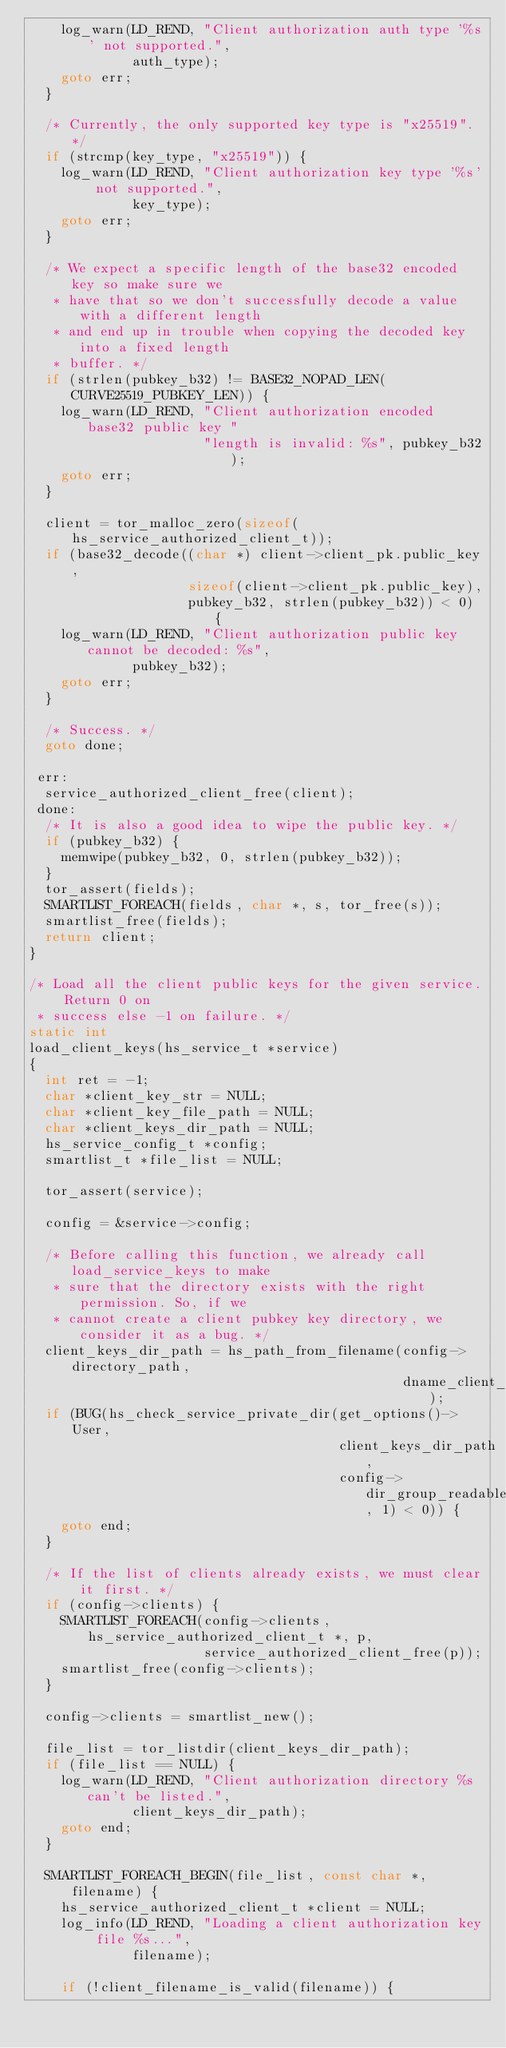Convert code to text. <code><loc_0><loc_0><loc_500><loc_500><_C_>    log_warn(LD_REND, "Client authorization auth type '%s' not supported.",
             auth_type);
    goto err;
  }

  /* Currently, the only supported key type is "x25519". */
  if (strcmp(key_type, "x25519")) {
    log_warn(LD_REND, "Client authorization key type '%s' not supported.",
             key_type);
    goto err;
  }

  /* We expect a specific length of the base32 encoded key so make sure we
   * have that so we don't successfully decode a value with a different length
   * and end up in trouble when copying the decoded key into a fixed length
   * buffer. */
  if (strlen(pubkey_b32) != BASE32_NOPAD_LEN(CURVE25519_PUBKEY_LEN)) {
    log_warn(LD_REND, "Client authorization encoded base32 public key "
                      "length is invalid: %s", pubkey_b32);
    goto err;
  }

  client = tor_malloc_zero(sizeof(hs_service_authorized_client_t));
  if (base32_decode((char *) client->client_pk.public_key,
                    sizeof(client->client_pk.public_key),
                    pubkey_b32, strlen(pubkey_b32)) < 0) {
    log_warn(LD_REND, "Client authorization public key cannot be decoded: %s",
             pubkey_b32);
    goto err;
  }

  /* Success. */
  goto done;

 err:
  service_authorized_client_free(client);
 done:
  /* It is also a good idea to wipe the public key. */
  if (pubkey_b32) {
    memwipe(pubkey_b32, 0, strlen(pubkey_b32));
  }
  tor_assert(fields);
  SMARTLIST_FOREACH(fields, char *, s, tor_free(s));
  smartlist_free(fields);
  return client;
}

/* Load all the client public keys for the given service. Return 0 on
 * success else -1 on failure. */
static int
load_client_keys(hs_service_t *service)
{
  int ret = -1;
  char *client_key_str = NULL;
  char *client_key_file_path = NULL;
  char *client_keys_dir_path = NULL;
  hs_service_config_t *config;
  smartlist_t *file_list = NULL;

  tor_assert(service);

  config = &service->config;

  /* Before calling this function, we already call load_service_keys to make
   * sure that the directory exists with the right permission. So, if we
   * cannot create a client pubkey key directory, we consider it as a bug. */
  client_keys_dir_path = hs_path_from_filename(config->directory_path,
                                               dname_client_pubkeys);
  if (BUG(hs_check_service_private_dir(get_options()->User,
                                       client_keys_dir_path,
                                       config->dir_group_readable, 1) < 0)) {
    goto end;
  }

  /* If the list of clients already exists, we must clear it first. */
  if (config->clients) {
    SMARTLIST_FOREACH(config->clients, hs_service_authorized_client_t *, p,
                      service_authorized_client_free(p));
    smartlist_free(config->clients);
  }

  config->clients = smartlist_new();

  file_list = tor_listdir(client_keys_dir_path);
  if (file_list == NULL) {
    log_warn(LD_REND, "Client authorization directory %s can't be listed.",
             client_keys_dir_path);
    goto end;
  }

  SMARTLIST_FOREACH_BEGIN(file_list, const char *, filename) {
    hs_service_authorized_client_t *client = NULL;
    log_info(LD_REND, "Loading a client authorization key file %s...",
             filename);

    if (!client_filename_is_valid(filename)) {</code> 